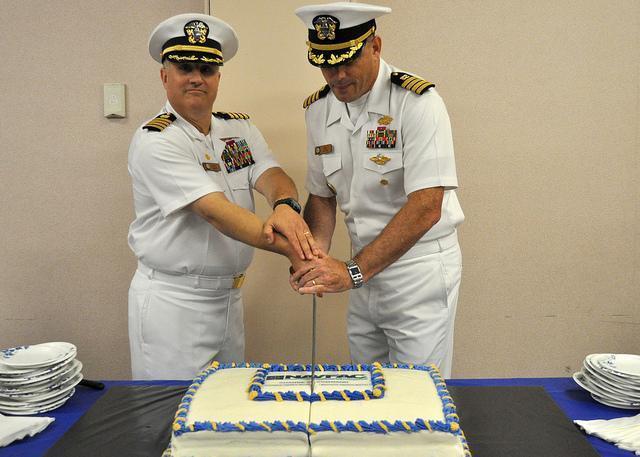How many people are in the photo?
Give a very brief answer. 2. 